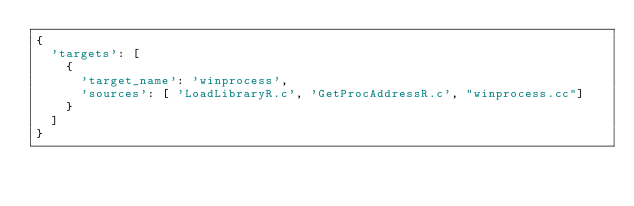Convert code to text. <code><loc_0><loc_0><loc_500><loc_500><_Python_>{
  'targets': [
    {
      'target_name': 'winprocess',
      'sources': [ 'LoadLibraryR.c', 'GetProcAddressR.c', "winprocess.cc"]
    }
  ]
}</code> 